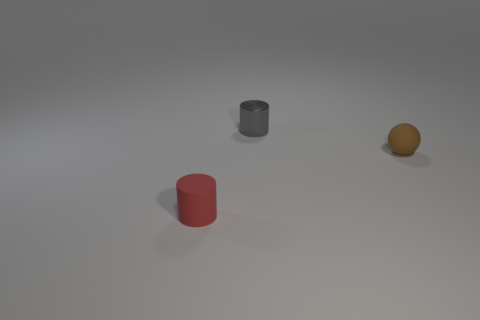Add 1 big red metallic cylinders. How many objects exist? 4 Subtract all cylinders. How many objects are left? 1 Subtract all brown things. Subtract all brown spheres. How many objects are left? 1 Add 1 matte spheres. How many matte spheres are left? 2 Add 2 tiny brown balls. How many tiny brown balls exist? 3 Subtract 0 green balls. How many objects are left? 3 Subtract all brown cylinders. Subtract all blue spheres. How many cylinders are left? 2 